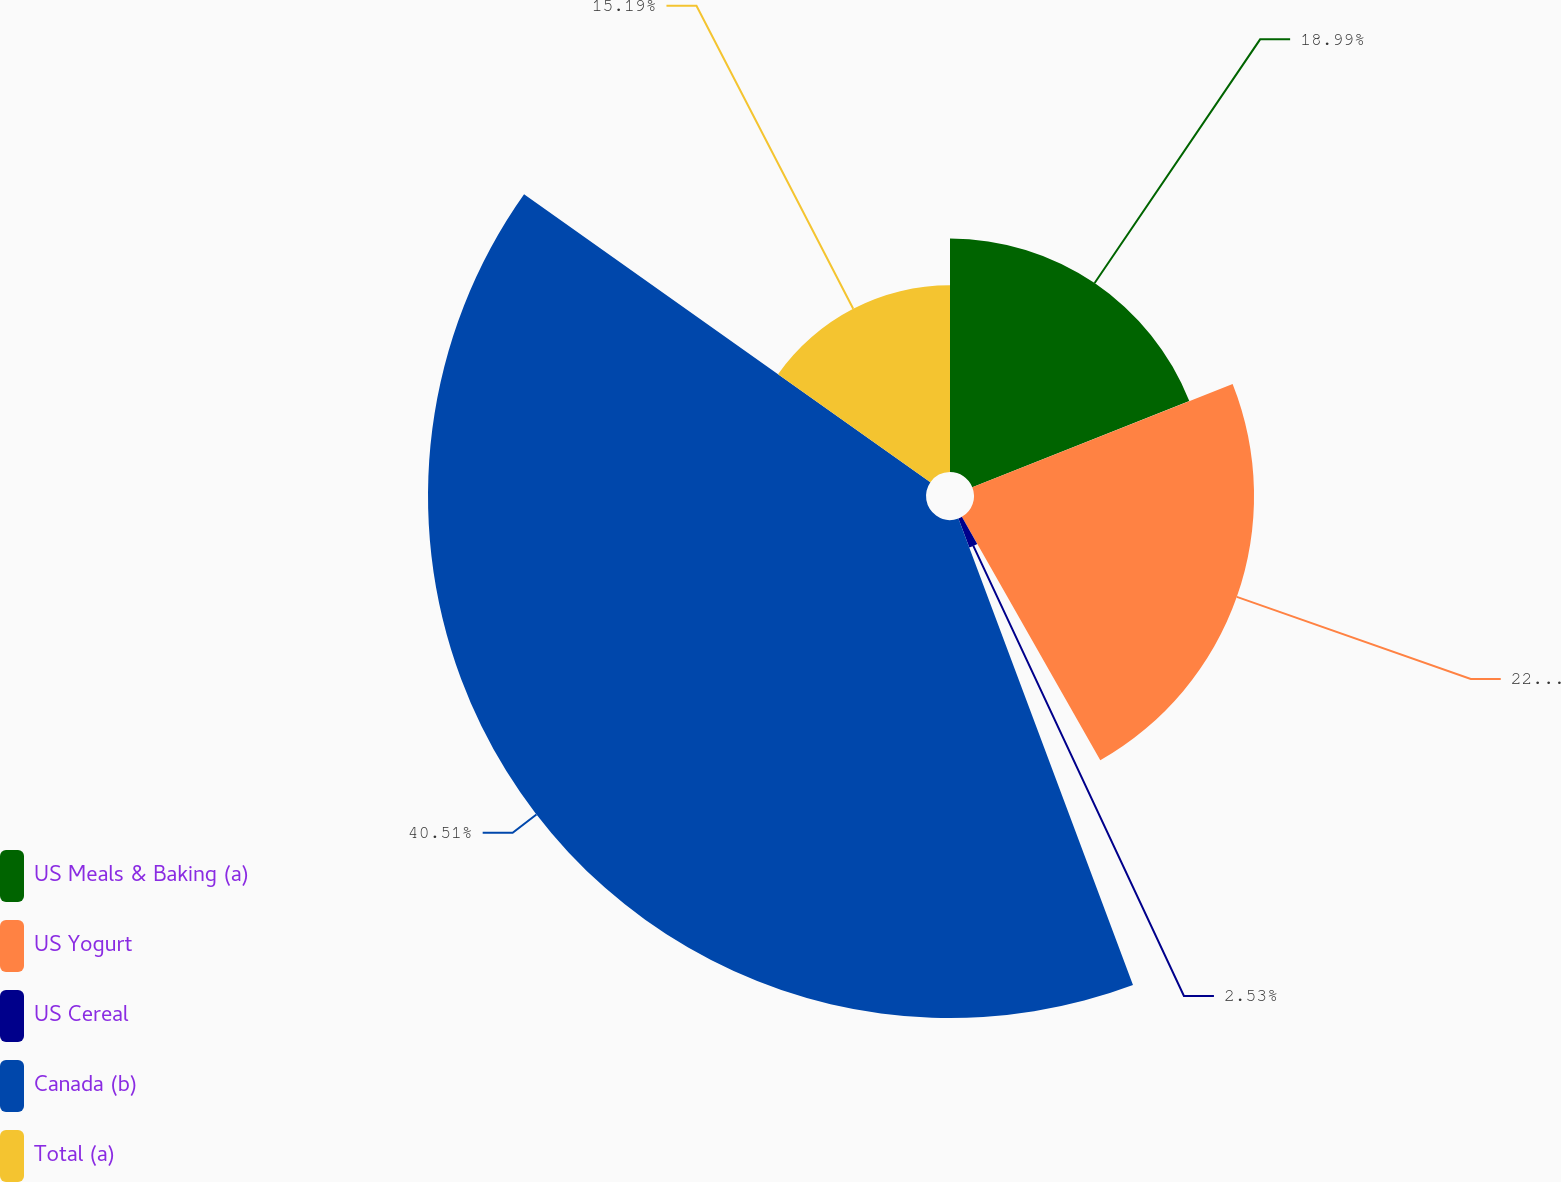Convert chart to OTSL. <chart><loc_0><loc_0><loc_500><loc_500><pie_chart><fcel>US Meals & Baking (a)<fcel>US Yogurt<fcel>US Cereal<fcel>Canada (b)<fcel>Total (a)<nl><fcel>18.99%<fcel>22.78%<fcel>2.53%<fcel>40.51%<fcel>15.19%<nl></chart> 